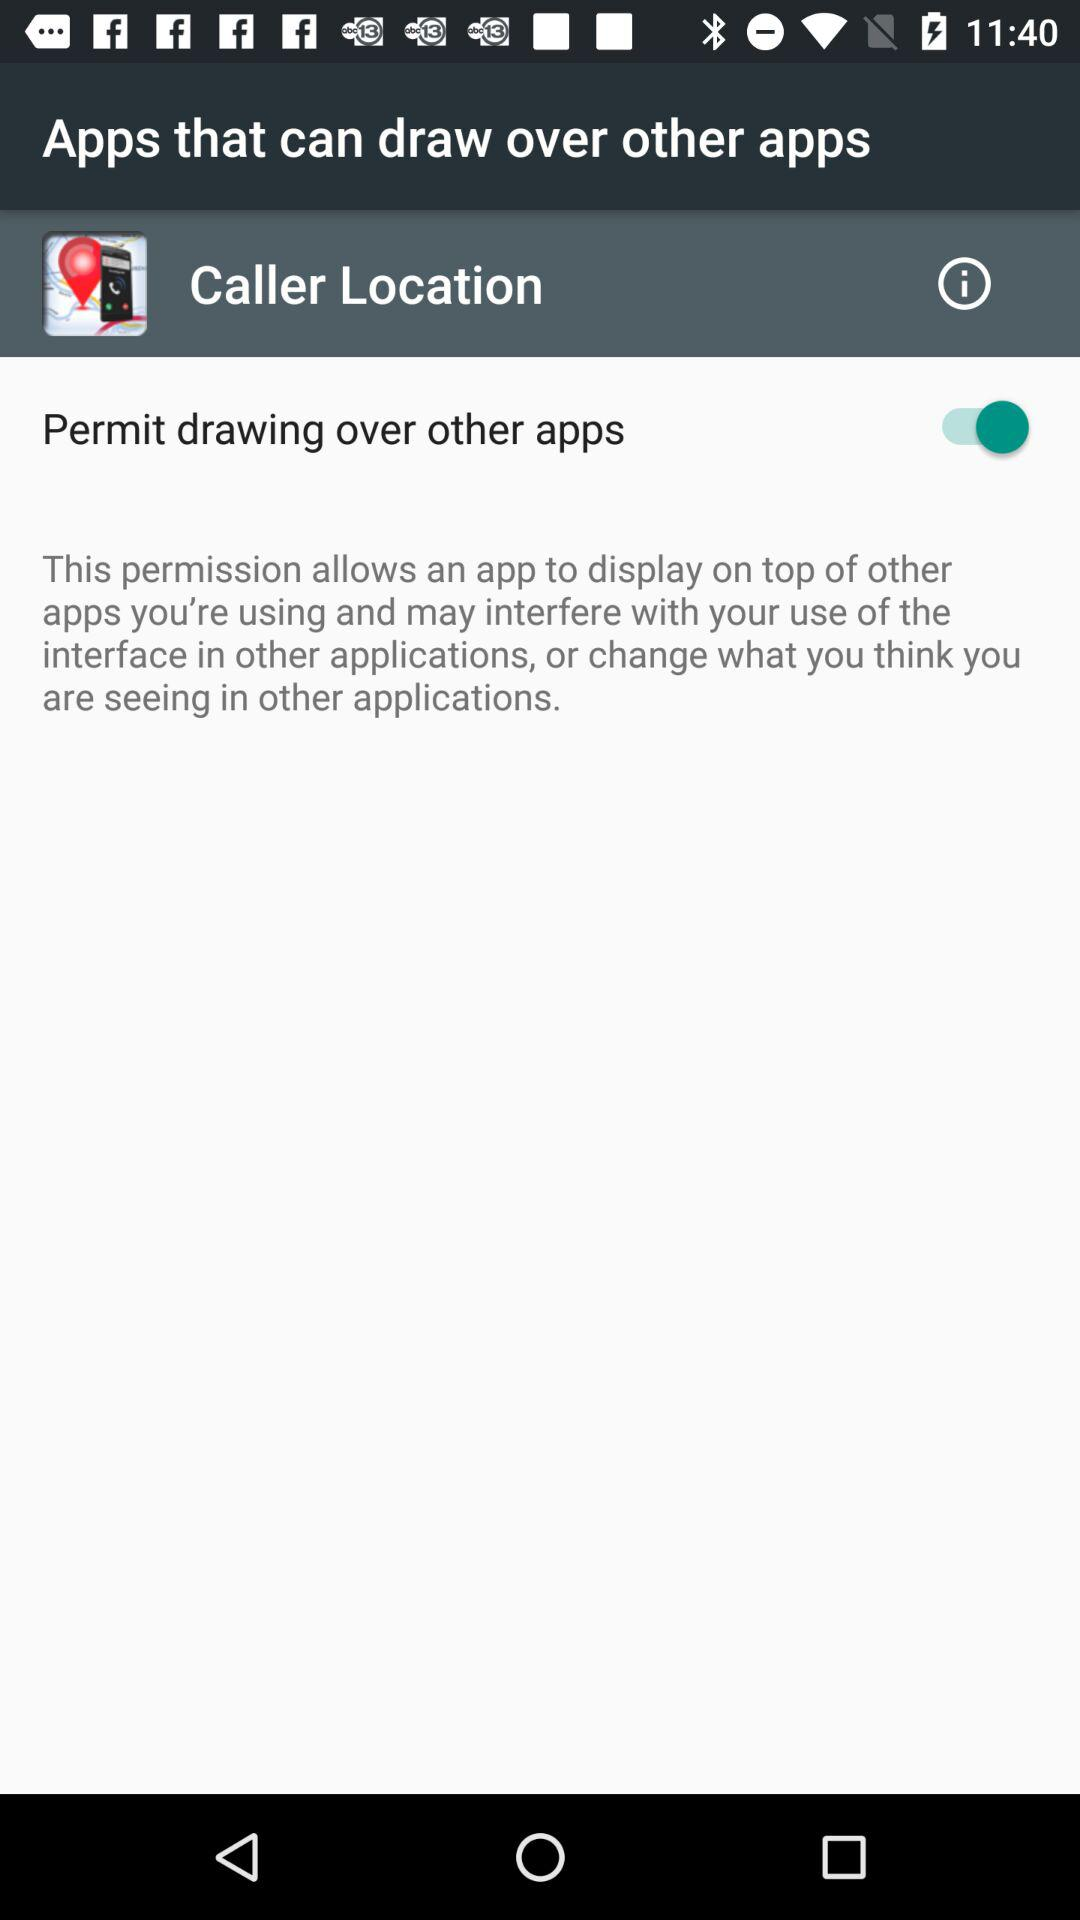What is the status of "Permit drawing over other apps"? The status is "on". 